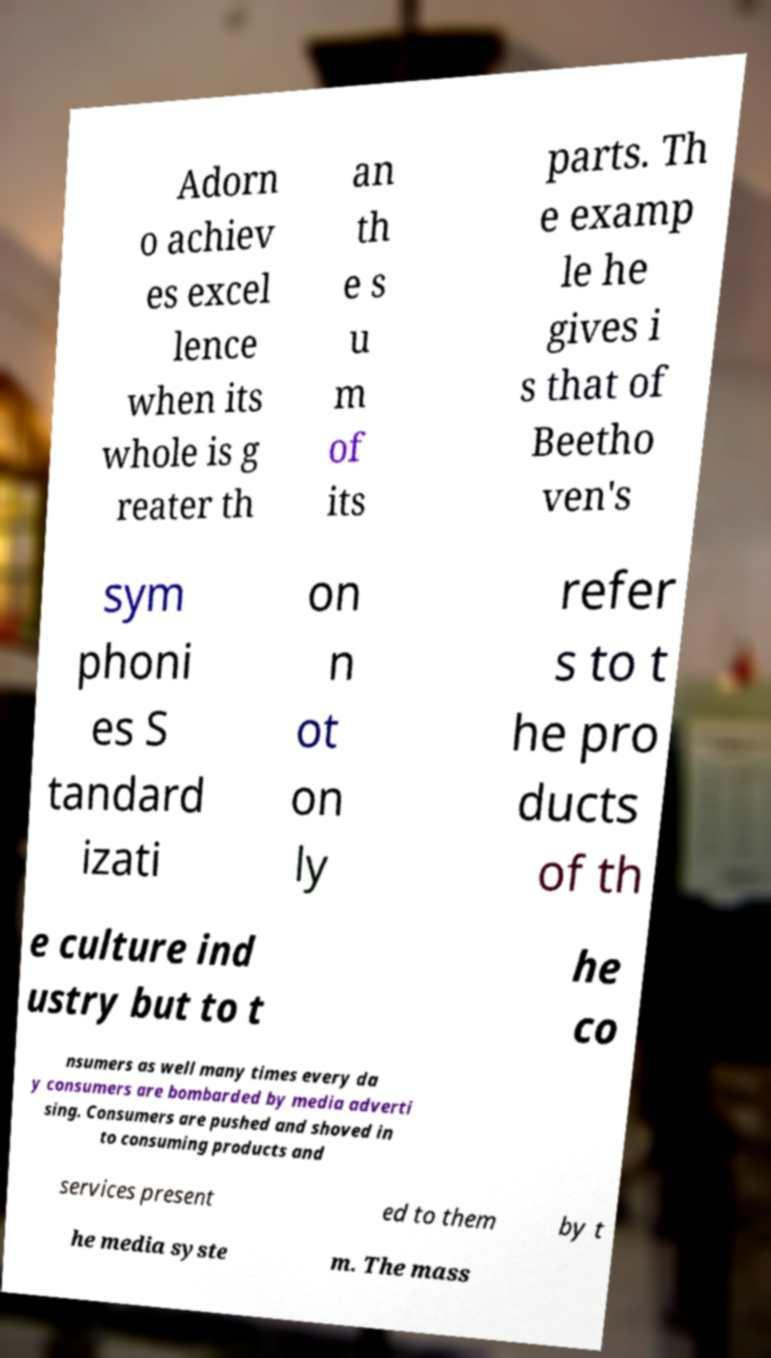Please read and relay the text visible in this image. What does it say? Adorn o achiev es excel lence when its whole is g reater th an th e s u m of its parts. Th e examp le he gives i s that of Beetho ven's sym phoni es S tandard izati on n ot on ly refer s to t he pro ducts of th e culture ind ustry but to t he co nsumers as well many times every da y consumers are bombarded by media adverti sing. Consumers are pushed and shoved in to consuming products and services present ed to them by t he media syste m. The mass 